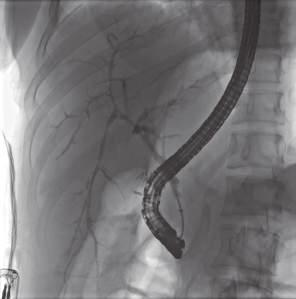what is a bile duct undergoing degeneration entrapped in?
Answer the question using a single word or phrase. A dense 